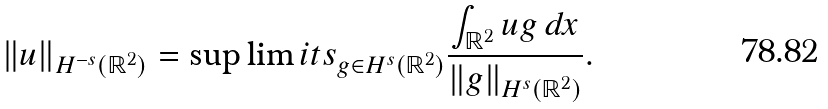<formula> <loc_0><loc_0><loc_500><loc_500>\| u \| _ { H ^ { - s } ( \mathbb { R } ^ { 2 } ) } = \sup \lim i t s _ { g \in H ^ { s } ( \mathbb { R } ^ { 2 } ) } \frac { \int _ { \mathbb { R } ^ { 2 } } u g \, d x } { \| g \| _ { H ^ { s } ( \mathbb { R } ^ { 2 } ) } } .</formula> 